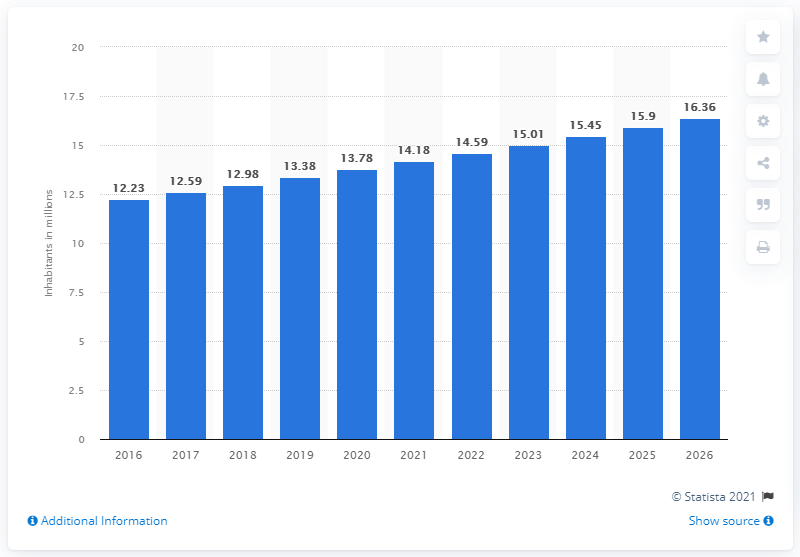Mention a couple of crucial points in this snapshot. As of 2020, the population of South Sudan was approximately 13.78 million people. 